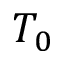<formula> <loc_0><loc_0><loc_500><loc_500>T _ { 0 }</formula> 